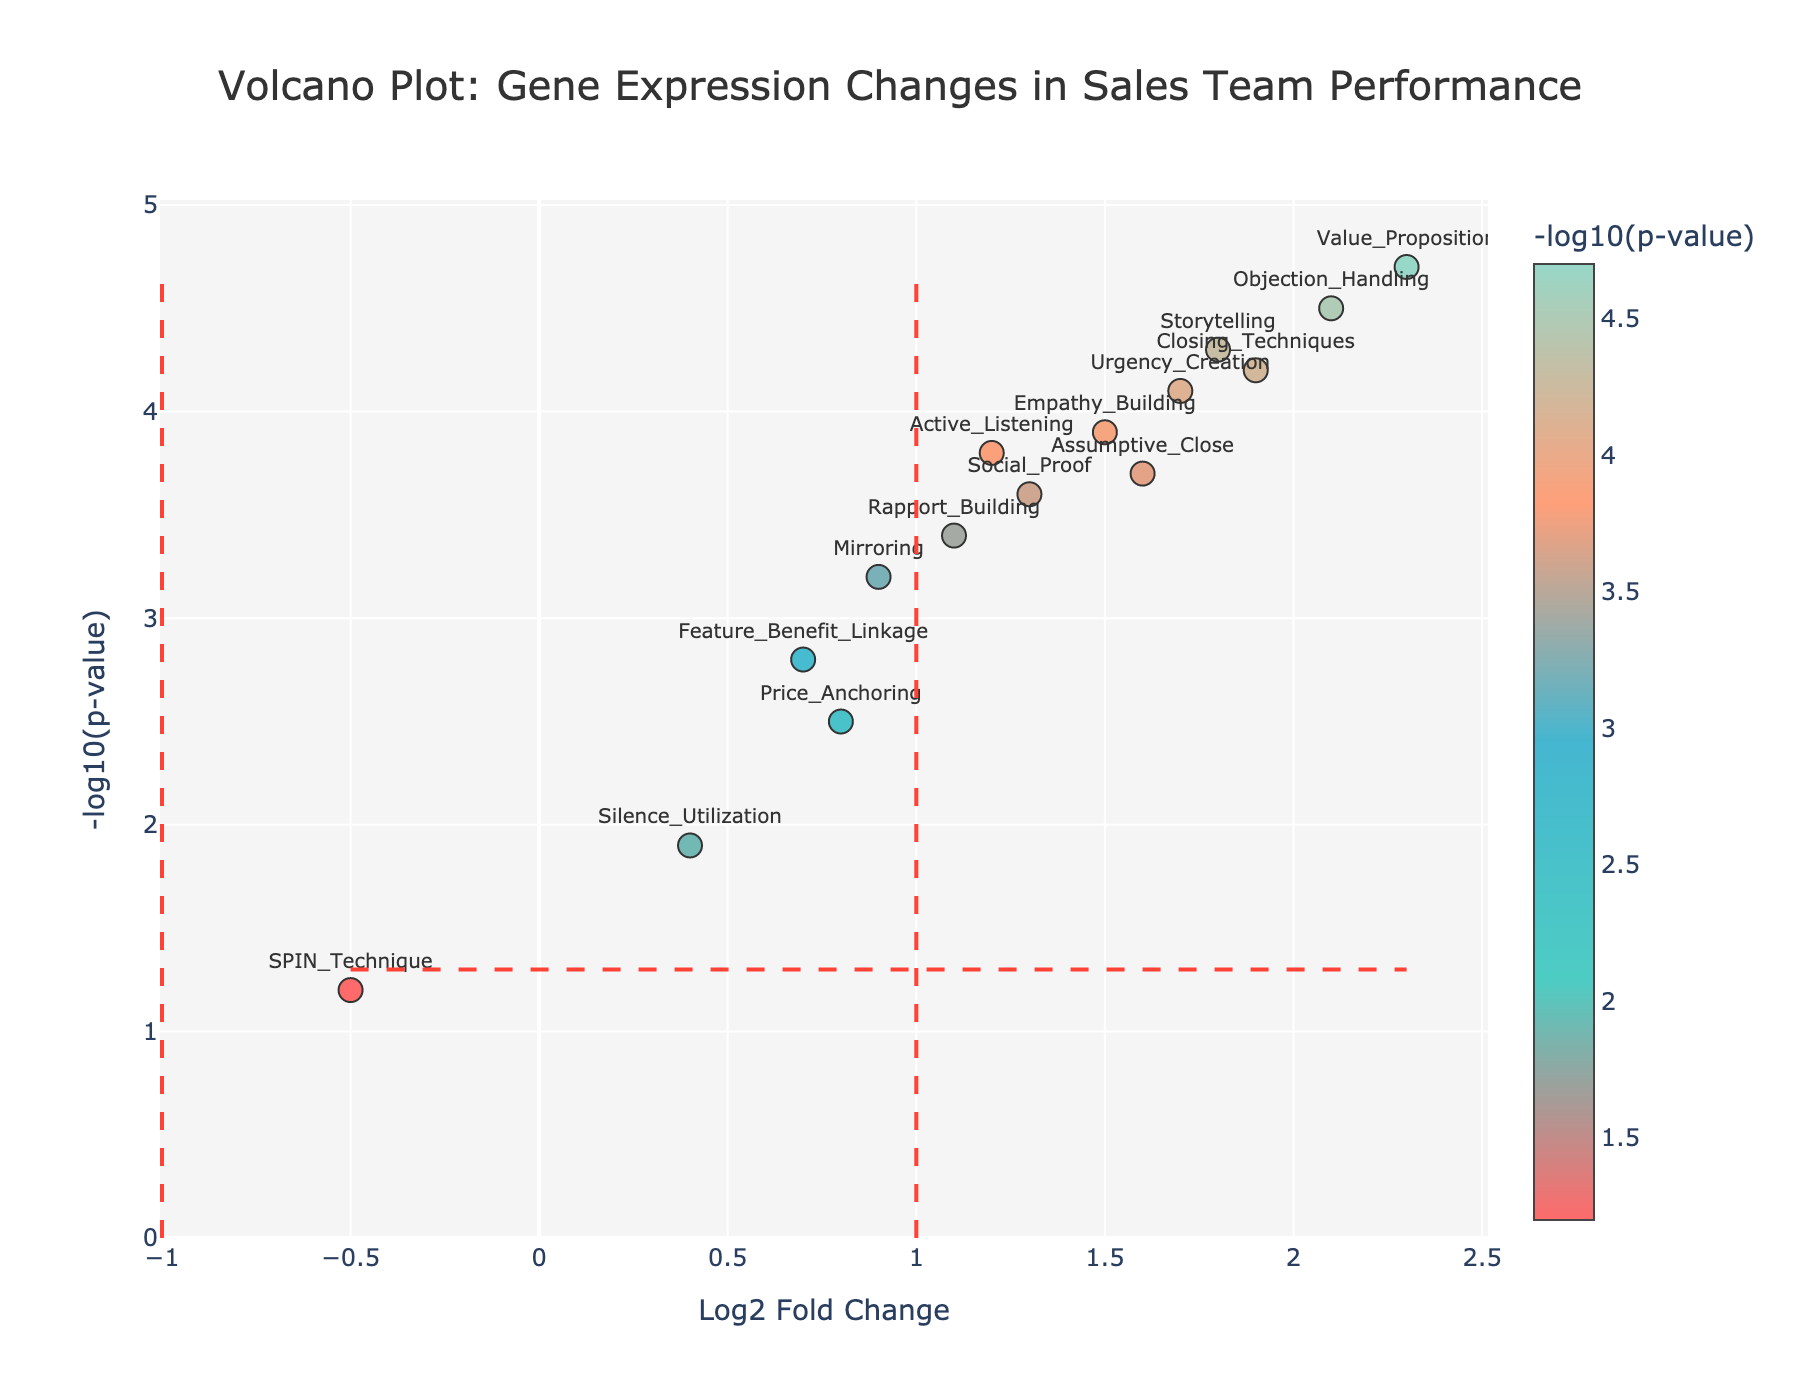What's the title of the figure? The title is located at the top center of the figure and is styled in a larger, prominent font. It reads “Volcano Plot: Gene Expression Changes in Sales Team Performance.”
Answer: Volcano Plot: Gene Expression Changes in Sales Team Performance What is displayed on the x-axis? The x-axis title is clearly labeled at the bottom of the figure. It indicates the metric being used for the horizontal axis, which is "Log2 Fold Change."
Answer: Log2 Fold Change How many genes have a Log2 Fold Change greater than 1? By examining the scatter plot, you identify points on the right side of the figure where the Log2 Fold Change is greater than 1. Count the number of these points.
Answer: 8 Which gene shows the highest Log2 Fold Change? Look at the x-axis values and identify the point that is furthest to the right. This corresponds to the gene with the highest Log2 Fold Change.
Answer: Value_Proposition What is the value on the y-axis that corresponds to Storytelling? Identify the point labeled "Storytelling" and read its y-axis value, which is indicated by its vertical position on the plot.
Answer: 4.3 How many genes have a NegativeLog10PValue greater than 3? Count the number of points that are above the y-value of 3 on the plot to get the number of genes with a NegativeLog10PValue greater than 3.
Answer: 10 Which gene is closest to the point (1, 1.3)? Locate the point (1, 1.3) on the plot and determine which labeled point is closest to this coordinate.
Answer: Urgency_Creation Comparing Active_Listening and Objection_Handling, which has a higher NegativeLog10PValue? Find the points corresponding to "Active_Listening" and "Objection_Handling" and compare their y-axis values to determine which is higher.
Answer: Objection_Handling How many genes are left of the x=-1 vertical line? Examine the points to the left side of the vertical dashed line at x=-1 and count how many are present.
Answer: 1 How many genes fall below the y=1.3 horizontal line? Observe the points below the horizontal dashed line at y=1.3 and count the total number of points.
Answer: 2 